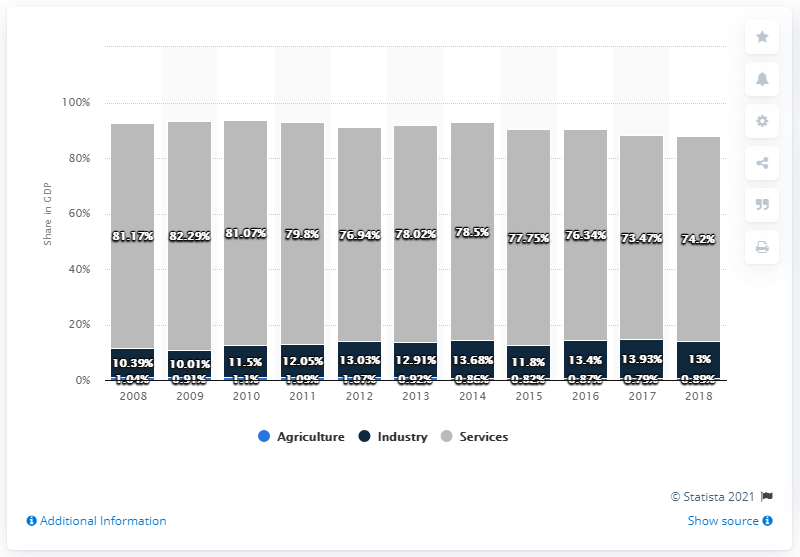List a handful of essential elements in this visual. The maximum value of industry over years is 13.93. The smallest gray bar in the bar graph represents a value of 74.2. In 2018, the agriculture sector accounted for 0.89% of the Bahamas' gross domestic product. 